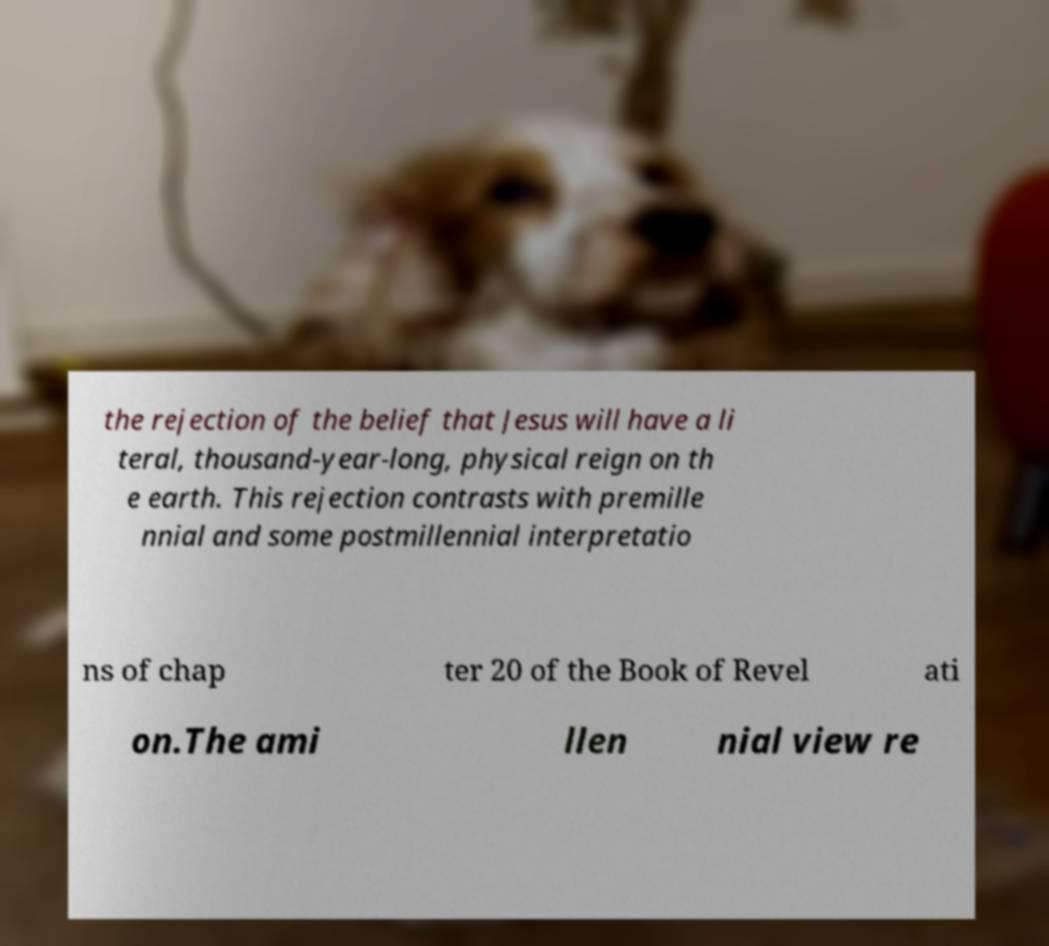Can you read and provide the text displayed in the image?This photo seems to have some interesting text. Can you extract and type it out for me? the rejection of the belief that Jesus will have a li teral, thousand-year-long, physical reign on th e earth. This rejection contrasts with premille nnial and some postmillennial interpretatio ns of chap ter 20 of the Book of Revel ati on.The ami llen nial view re 